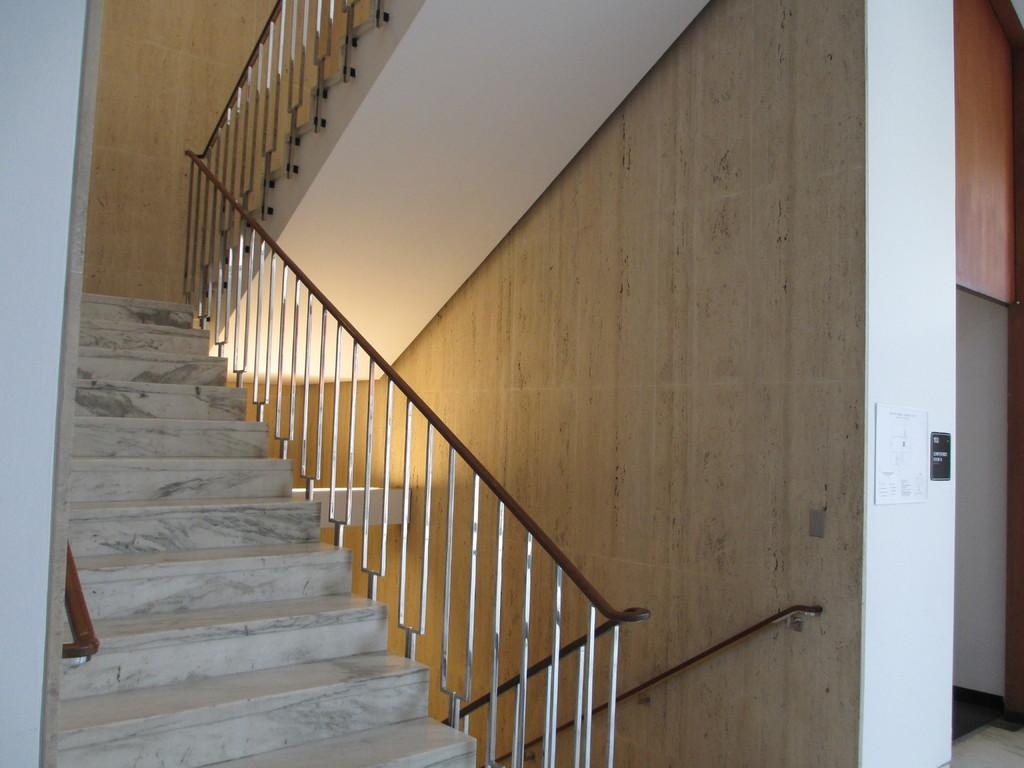What type of architectural feature is present in the image? There are stairs in the image. What else can be seen in the image besides the stairs? There are poles and posters on the wall in the image. Where is the image taken? The image is set inside a building. What type of waves can be seen in the image? There are no waves present in the image; it is set inside a building with stairs, poles, and posters on the wall. 